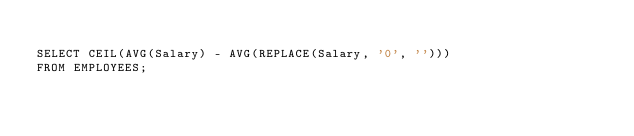<code> <loc_0><loc_0><loc_500><loc_500><_SQL_>
SELECT CEIL(AVG(Salary) - AVG(REPLACE(Salary, '0', '')))
FROM EMPLOYEES;
</code> 